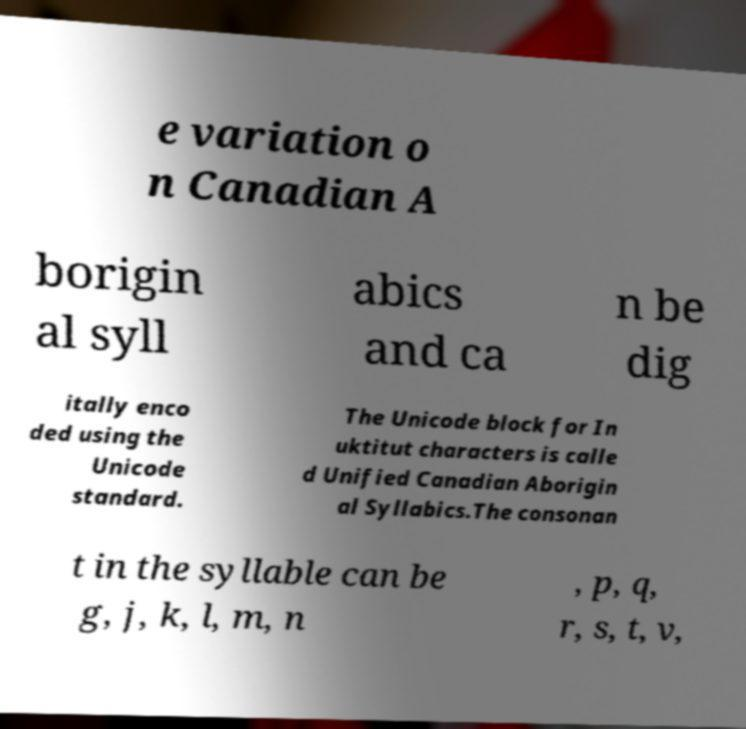I need the written content from this picture converted into text. Can you do that? e variation o n Canadian A borigin al syll abics and ca n be dig itally enco ded using the Unicode standard. The Unicode block for In uktitut characters is calle d Unified Canadian Aborigin al Syllabics.The consonan t in the syllable can be g, j, k, l, m, n , p, q, r, s, t, v, 